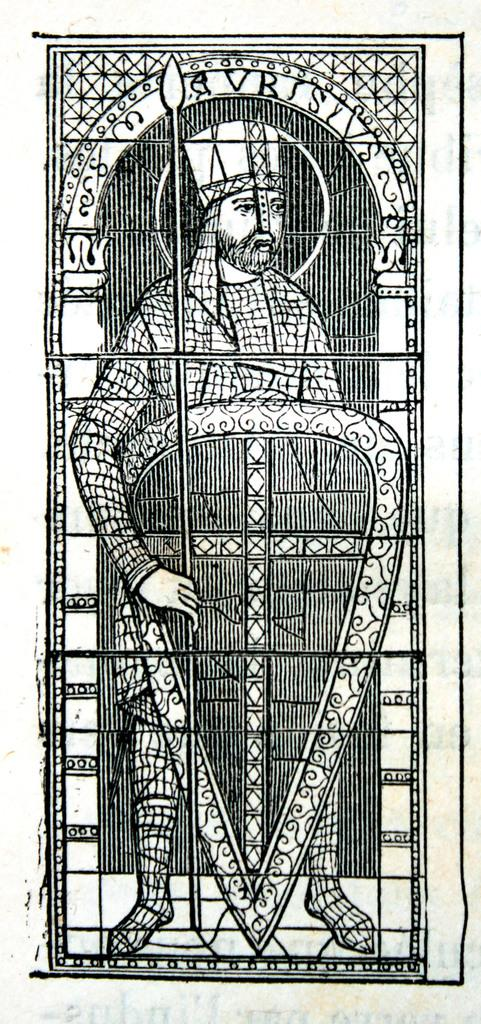What is the nature of the image? The image appears to be a drawing. Can you describe the person in the drawing? There is a person standing in the drawing, holding a war shield and a weapon. What might the person be depicted as doing in the drawing? The person may be depicted as preparing for battle or engaging in combat. Are there any additional elements in the image besides the person and their weapons? Yes, there are letters in the image, possibly part of the drawing or a separate observation. What month is depicted in the drawing? There is no specific month depicted in the drawing; it is a drawing of a person holding a war shield and a weapon. What shape is the yam in the drawing? There is no yam present in the drawing; it features a person holding a war shield and a weapon, along with letters. 